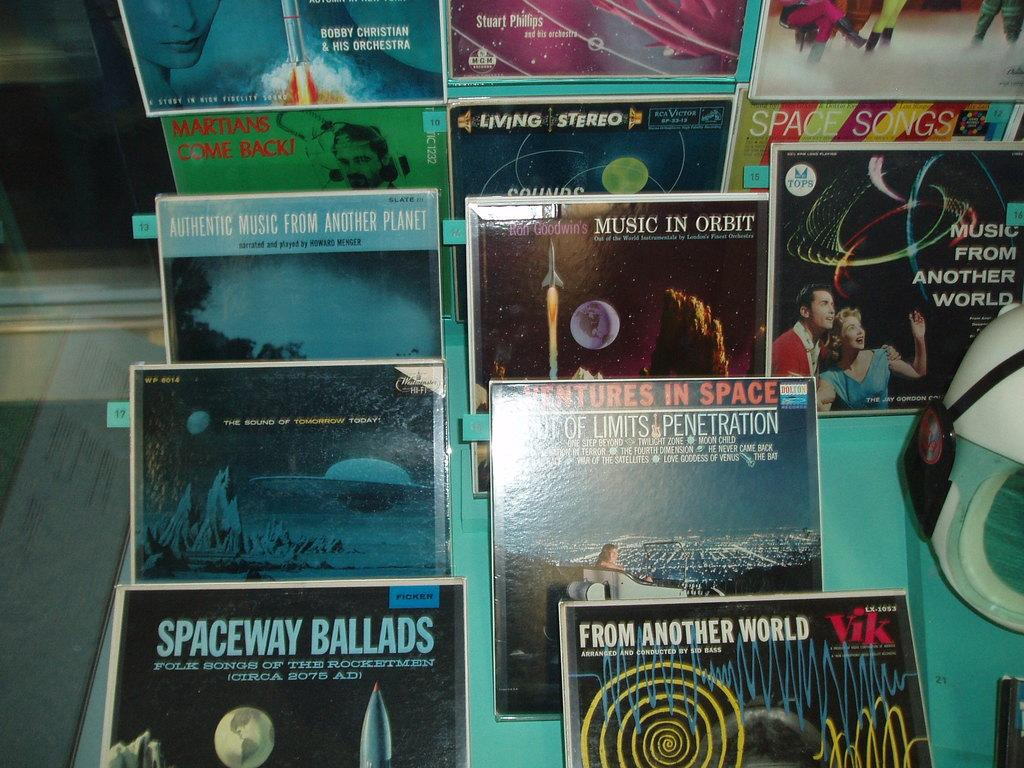<image>
Offer a succinct explanation of the picture presented. music records with one being called SPACEWAY BALLADS. 